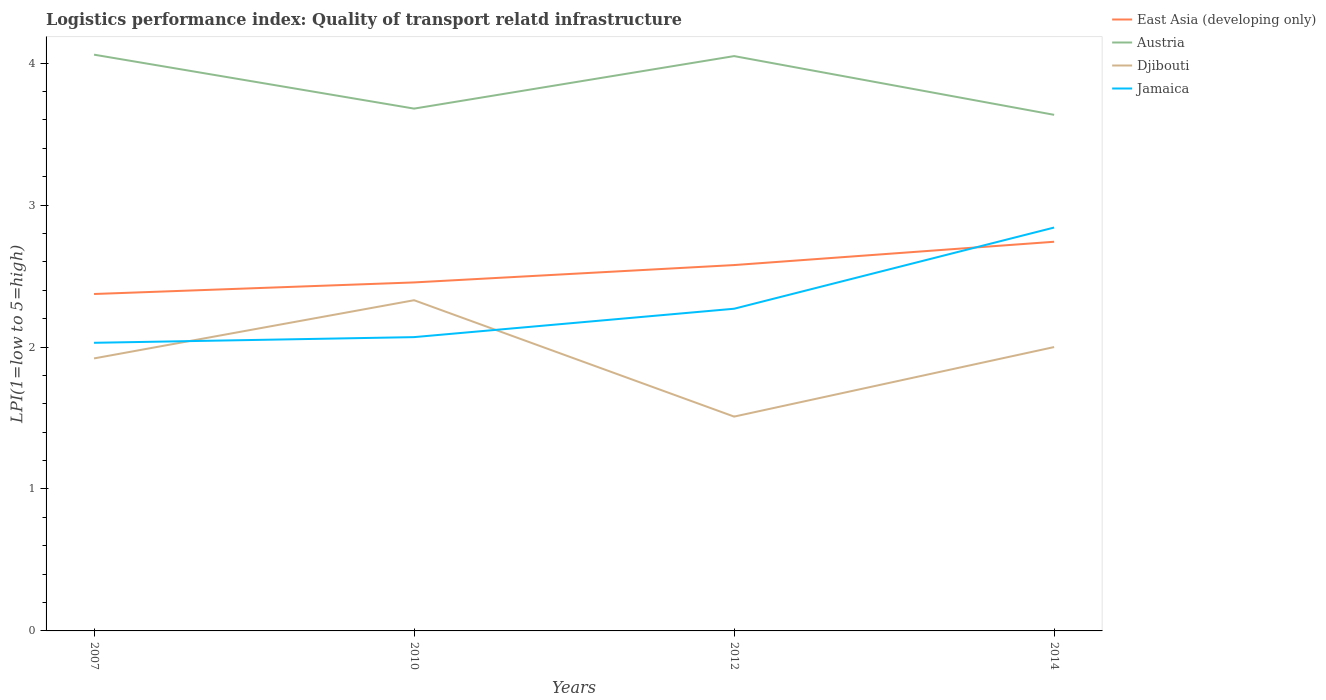How many different coloured lines are there?
Provide a succinct answer. 4. Does the line corresponding to Djibouti intersect with the line corresponding to Jamaica?
Your answer should be compact. Yes. Is the number of lines equal to the number of legend labels?
Give a very brief answer. Yes. Across all years, what is the maximum logistics performance index in Djibouti?
Your answer should be very brief. 1.51. In which year was the logistics performance index in East Asia (developing only) maximum?
Your answer should be compact. 2007. What is the total logistics performance index in Austria in the graph?
Your answer should be very brief. 0.38. What is the difference between the highest and the second highest logistics performance index in Djibouti?
Your response must be concise. 0.82. Is the logistics performance index in East Asia (developing only) strictly greater than the logistics performance index in Austria over the years?
Offer a terse response. Yes. Are the values on the major ticks of Y-axis written in scientific E-notation?
Ensure brevity in your answer.  No. Does the graph contain grids?
Provide a short and direct response. No. Where does the legend appear in the graph?
Make the answer very short. Top right. How many legend labels are there?
Offer a very short reply. 4. How are the legend labels stacked?
Offer a terse response. Vertical. What is the title of the graph?
Provide a short and direct response. Logistics performance index: Quality of transport relatd infrastructure. What is the label or title of the Y-axis?
Provide a short and direct response. LPI(1=low to 5=high). What is the LPI(1=low to 5=high) of East Asia (developing only) in 2007?
Keep it short and to the point. 2.37. What is the LPI(1=low to 5=high) of Austria in 2007?
Your answer should be very brief. 4.06. What is the LPI(1=low to 5=high) of Djibouti in 2007?
Your answer should be very brief. 1.92. What is the LPI(1=low to 5=high) in Jamaica in 2007?
Provide a succinct answer. 2.03. What is the LPI(1=low to 5=high) in East Asia (developing only) in 2010?
Your answer should be very brief. 2.46. What is the LPI(1=low to 5=high) of Austria in 2010?
Your response must be concise. 3.68. What is the LPI(1=low to 5=high) of Djibouti in 2010?
Provide a short and direct response. 2.33. What is the LPI(1=low to 5=high) of Jamaica in 2010?
Your response must be concise. 2.07. What is the LPI(1=low to 5=high) in East Asia (developing only) in 2012?
Make the answer very short. 2.58. What is the LPI(1=low to 5=high) in Austria in 2012?
Your response must be concise. 4.05. What is the LPI(1=low to 5=high) in Djibouti in 2012?
Give a very brief answer. 1.51. What is the LPI(1=low to 5=high) in Jamaica in 2012?
Your answer should be very brief. 2.27. What is the LPI(1=low to 5=high) in East Asia (developing only) in 2014?
Your answer should be compact. 2.74. What is the LPI(1=low to 5=high) in Austria in 2014?
Offer a terse response. 3.64. What is the LPI(1=low to 5=high) in Jamaica in 2014?
Provide a succinct answer. 2.84. Across all years, what is the maximum LPI(1=low to 5=high) of East Asia (developing only)?
Make the answer very short. 2.74. Across all years, what is the maximum LPI(1=low to 5=high) in Austria?
Ensure brevity in your answer.  4.06. Across all years, what is the maximum LPI(1=low to 5=high) in Djibouti?
Your answer should be compact. 2.33. Across all years, what is the maximum LPI(1=low to 5=high) of Jamaica?
Offer a very short reply. 2.84. Across all years, what is the minimum LPI(1=low to 5=high) in East Asia (developing only)?
Provide a succinct answer. 2.37. Across all years, what is the minimum LPI(1=low to 5=high) in Austria?
Provide a short and direct response. 3.64. Across all years, what is the minimum LPI(1=low to 5=high) of Djibouti?
Ensure brevity in your answer.  1.51. Across all years, what is the minimum LPI(1=low to 5=high) of Jamaica?
Make the answer very short. 2.03. What is the total LPI(1=low to 5=high) of East Asia (developing only) in the graph?
Give a very brief answer. 10.15. What is the total LPI(1=low to 5=high) in Austria in the graph?
Your answer should be very brief. 15.43. What is the total LPI(1=low to 5=high) of Djibouti in the graph?
Provide a short and direct response. 7.76. What is the total LPI(1=low to 5=high) of Jamaica in the graph?
Provide a short and direct response. 9.21. What is the difference between the LPI(1=low to 5=high) in East Asia (developing only) in 2007 and that in 2010?
Ensure brevity in your answer.  -0.08. What is the difference between the LPI(1=low to 5=high) of Austria in 2007 and that in 2010?
Keep it short and to the point. 0.38. What is the difference between the LPI(1=low to 5=high) of Djibouti in 2007 and that in 2010?
Keep it short and to the point. -0.41. What is the difference between the LPI(1=low to 5=high) in Jamaica in 2007 and that in 2010?
Offer a very short reply. -0.04. What is the difference between the LPI(1=low to 5=high) in East Asia (developing only) in 2007 and that in 2012?
Your answer should be very brief. -0.2. What is the difference between the LPI(1=low to 5=high) of Djibouti in 2007 and that in 2012?
Ensure brevity in your answer.  0.41. What is the difference between the LPI(1=low to 5=high) in Jamaica in 2007 and that in 2012?
Ensure brevity in your answer.  -0.24. What is the difference between the LPI(1=low to 5=high) in East Asia (developing only) in 2007 and that in 2014?
Offer a very short reply. -0.37. What is the difference between the LPI(1=low to 5=high) in Austria in 2007 and that in 2014?
Give a very brief answer. 0.42. What is the difference between the LPI(1=low to 5=high) of Djibouti in 2007 and that in 2014?
Your response must be concise. -0.08. What is the difference between the LPI(1=low to 5=high) in Jamaica in 2007 and that in 2014?
Make the answer very short. -0.81. What is the difference between the LPI(1=low to 5=high) of East Asia (developing only) in 2010 and that in 2012?
Make the answer very short. -0.12. What is the difference between the LPI(1=low to 5=high) in Austria in 2010 and that in 2012?
Your response must be concise. -0.37. What is the difference between the LPI(1=low to 5=high) in Djibouti in 2010 and that in 2012?
Your response must be concise. 0.82. What is the difference between the LPI(1=low to 5=high) of East Asia (developing only) in 2010 and that in 2014?
Your response must be concise. -0.29. What is the difference between the LPI(1=low to 5=high) of Austria in 2010 and that in 2014?
Your response must be concise. 0.04. What is the difference between the LPI(1=low to 5=high) in Djibouti in 2010 and that in 2014?
Keep it short and to the point. 0.33. What is the difference between the LPI(1=low to 5=high) of Jamaica in 2010 and that in 2014?
Provide a short and direct response. -0.77. What is the difference between the LPI(1=low to 5=high) of East Asia (developing only) in 2012 and that in 2014?
Keep it short and to the point. -0.16. What is the difference between the LPI(1=low to 5=high) of Austria in 2012 and that in 2014?
Provide a succinct answer. 0.41. What is the difference between the LPI(1=low to 5=high) of Djibouti in 2012 and that in 2014?
Provide a short and direct response. -0.49. What is the difference between the LPI(1=low to 5=high) of Jamaica in 2012 and that in 2014?
Offer a terse response. -0.57. What is the difference between the LPI(1=low to 5=high) of East Asia (developing only) in 2007 and the LPI(1=low to 5=high) of Austria in 2010?
Make the answer very short. -1.31. What is the difference between the LPI(1=low to 5=high) of East Asia (developing only) in 2007 and the LPI(1=low to 5=high) of Djibouti in 2010?
Your answer should be very brief. 0.04. What is the difference between the LPI(1=low to 5=high) of East Asia (developing only) in 2007 and the LPI(1=low to 5=high) of Jamaica in 2010?
Keep it short and to the point. 0.3. What is the difference between the LPI(1=low to 5=high) in Austria in 2007 and the LPI(1=low to 5=high) in Djibouti in 2010?
Offer a terse response. 1.73. What is the difference between the LPI(1=low to 5=high) of Austria in 2007 and the LPI(1=low to 5=high) of Jamaica in 2010?
Provide a succinct answer. 1.99. What is the difference between the LPI(1=low to 5=high) in East Asia (developing only) in 2007 and the LPI(1=low to 5=high) in Austria in 2012?
Make the answer very short. -1.68. What is the difference between the LPI(1=low to 5=high) in East Asia (developing only) in 2007 and the LPI(1=low to 5=high) in Djibouti in 2012?
Ensure brevity in your answer.  0.86. What is the difference between the LPI(1=low to 5=high) in East Asia (developing only) in 2007 and the LPI(1=low to 5=high) in Jamaica in 2012?
Offer a terse response. 0.1. What is the difference between the LPI(1=low to 5=high) of Austria in 2007 and the LPI(1=low to 5=high) of Djibouti in 2012?
Your answer should be very brief. 2.55. What is the difference between the LPI(1=low to 5=high) in Austria in 2007 and the LPI(1=low to 5=high) in Jamaica in 2012?
Ensure brevity in your answer.  1.79. What is the difference between the LPI(1=low to 5=high) of Djibouti in 2007 and the LPI(1=low to 5=high) of Jamaica in 2012?
Provide a succinct answer. -0.35. What is the difference between the LPI(1=low to 5=high) in East Asia (developing only) in 2007 and the LPI(1=low to 5=high) in Austria in 2014?
Provide a succinct answer. -1.26. What is the difference between the LPI(1=low to 5=high) of East Asia (developing only) in 2007 and the LPI(1=low to 5=high) of Djibouti in 2014?
Ensure brevity in your answer.  0.37. What is the difference between the LPI(1=low to 5=high) in East Asia (developing only) in 2007 and the LPI(1=low to 5=high) in Jamaica in 2014?
Provide a short and direct response. -0.47. What is the difference between the LPI(1=low to 5=high) of Austria in 2007 and the LPI(1=low to 5=high) of Djibouti in 2014?
Your answer should be compact. 2.06. What is the difference between the LPI(1=low to 5=high) of Austria in 2007 and the LPI(1=low to 5=high) of Jamaica in 2014?
Make the answer very short. 1.22. What is the difference between the LPI(1=low to 5=high) in Djibouti in 2007 and the LPI(1=low to 5=high) in Jamaica in 2014?
Provide a succinct answer. -0.92. What is the difference between the LPI(1=low to 5=high) of East Asia (developing only) in 2010 and the LPI(1=low to 5=high) of Austria in 2012?
Your answer should be very brief. -1.59. What is the difference between the LPI(1=low to 5=high) in East Asia (developing only) in 2010 and the LPI(1=low to 5=high) in Djibouti in 2012?
Offer a terse response. 0.95. What is the difference between the LPI(1=low to 5=high) of East Asia (developing only) in 2010 and the LPI(1=low to 5=high) of Jamaica in 2012?
Provide a succinct answer. 0.19. What is the difference between the LPI(1=low to 5=high) in Austria in 2010 and the LPI(1=low to 5=high) in Djibouti in 2012?
Ensure brevity in your answer.  2.17. What is the difference between the LPI(1=low to 5=high) of Austria in 2010 and the LPI(1=low to 5=high) of Jamaica in 2012?
Ensure brevity in your answer.  1.41. What is the difference between the LPI(1=low to 5=high) of East Asia (developing only) in 2010 and the LPI(1=low to 5=high) of Austria in 2014?
Offer a terse response. -1.18. What is the difference between the LPI(1=low to 5=high) of East Asia (developing only) in 2010 and the LPI(1=low to 5=high) of Djibouti in 2014?
Offer a terse response. 0.46. What is the difference between the LPI(1=low to 5=high) of East Asia (developing only) in 2010 and the LPI(1=low to 5=high) of Jamaica in 2014?
Your answer should be compact. -0.39. What is the difference between the LPI(1=low to 5=high) in Austria in 2010 and the LPI(1=low to 5=high) in Djibouti in 2014?
Make the answer very short. 1.68. What is the difference between the LPI(1=low to 5=high) in Austria in 2010 and the LPI(1=low to 5=high) in Jamaica in 2014?
Provide a succinct answer. 0.84. What is the difference between the LPI(1=low to 5=high) in Djibouti in 2010 and the LPI(1=low to 5=high) in Jamaica in 2014?
Offer a very short reply. -0.51. What is the difference between the LPI(1=low to 5=high) of East Asia (developing only) in 2012 and the LPI(1=low to 5=high) of Austria in 2014?
Offer a terse response. -1.06. What is the difference between the LPI(1=low to 5=high) in East Asia (developing only) in 2012 and the LPI(1=low to 5=high) in Djibouti in 2014?
Offer a terse response. 0.58. What is the difference between the LPI(1=low to 5=high) in East Asia (developing only) in 2012 and the LPI(1=low to 5=high) in Jamaica in 2014?
Give a very brief answer. -0.26. What is the difference between the LPI(1=low to 5=high) in Austria in 2012 and the LPI(1=low to 5=high) in Djibouti in 2014?
Give a very brief answer. 2.05. What is the difference between the LPI(1=low to 5=high) in Austria in 2012 and the LPI(1=low to 5=high) in Jamaica in 2014?
Keep it short and to the point. 1.21. What is the difference between the LPI(1=low to 5=high) of Djibouti in 2012 and the LPI(1=low to 5=high) of Jamaica in 2014?
Keep it short and to the point. -1.33. What is the average LPI(1=low to 5=high) in East Asia (developing only) per year?
Provide a succinct answer. 2.54. What is the average LPI(1=low to 5=high) of Austria per year?
Make the answer very short. 3.86. What is the average LPI(1=low to 5=high) of Djibouti per year?
Your answer should be very brief. 1.94. What is the average LPI(1=low to 5=high) in Jamaica per year?
Make the answer very short. 2.3. In the year 2007, what is the difference between the LPI(1=low to 5=high) in East Asia (developing only) and LPI(1=low to 5=high) in Austria?
Provide a short and direct response. -1.69. In the year 2007, what is the difference between the LPI(1=low to 5=high) in East Asia (developing only) and LPI(1=low to 5=high) in Djibouti?
Give a very brief answer. 0.45. In the year 2007, what is the difference between the LPI(1=low to 5=high) in East Asia (developing only) and LPI(1=low to 5=high) in Jamaica?
Offer a very short reply. 0.34. In the year 2007, what is the difference between the LPI(1=low to 5=high) in Austria and LPI(1=low to 5=high) in Djibouti?
Keep it short and to the point. 2.14. In the year 2007, what is the difference between the LPI(1=low to 5=high) in Austria and LPI(1=low to 5=high) in Jamaica?
Make the answer very short. 2.03. In the year 2007, what is the difference between the LPI(1=low to 5=high) of Djibouti and LPI(1=low to 5=high) of Jamaica?
Your answer should be very brief. -0.11. In the year 2010, what is the difference between the LPI(1=low to 5=high) of East Asia (developing only) and LPI(1=low to 5=high) of Austria?
Provide a succinct answer. -1.22. In the year 2010, what is the difference between the LPI(1=low to 5=high) in East Asia (developing only) and LPI(1=low to 5=high) in Djibouti?
Provide a short and direct response. 0.13. In the year 2010, what is the difference between the LPI(1=low to 5=high) of East Asia (developing only) and LPI(1=low to 5=high) of Jamaica?
Ensure brevity in your answer.  0.39. In the year 2010, what is the difference between the LPI(1=low to 5=high) of Austria and LPI(1=low to 5=high) of Djibouti?
Keep it short and to the point. 1.35. In the year 2010, what is the difference between the LPI(1=low to 5=high) in Austria and LPI(1=low to 5=high) in Jamaica?
Keep it short and to the point. 1.61. In the year 2010, what is the difference between the LPI(1=low to 5=high) of Djibouti and LPI(1=low to 5=high) of Jamaica?
Give a very brief answer. 0.26. In the year 2012, what is the difference between the LPI(1=low to 5=high) of East Asia (developing only) and LPI(1=low to 5=high) of Austria?
Your answer should be very brief. -1.47. In the year 2012, what is the difference between the LPI(1=low to 5=high) of East Asia (developing only) and LPI(1=low to 5=high) of Djibouti?
Your answer should be compact. 1.07. In the year 2012, what is the difference between the LPI(1=low to 5=high) of East Asia (developing only) and LPI(1=low to 5=high) of Jamaica?
Keep it short and to the point. 0.31. In the year 2012, what is the difference between the LPI(1=low to 5=high) of Austria and LPI(1=low to 5=high) of Djibouti?
Provide a succinct answer. 2.54. In the year 2012, what is the difference between the LPI(1=low to 5=high) of Austria and LPI(1=low to 5=high) of Jamaica?
Keep it short and to the point. 1.78. In the year 2012, what is the difference between the LPI(1=low to 5=high) of Djibouti and LPI(1=low to 5=high) of Jamaica?
Make the answer very short. -0.76. In the year 2014, what is the difference between the LPI(1=low to 5=high) of East Asia (developing only) and LPI(1=low to 5=high) of Austria?
Your answer should be compact. -0.89. In the year 2014, what is the difference between the LPI(1=low to 5=high) in East Asia (developing only) and LPI(1=low to 5=high) in Djibouti?
Make the answer very short. 0.74. In the year 2014, what is the difference between the LPI(1=low to 5=high) in East Asia (developing only) and LPI(1=low to 5=high) in Jamaica?
Give a very brief answer. -0.1. In the year 2014, what is the difference between the LPI(1=low to 5=high) of Austria and LPI(1=low to 5=high) of Djibouti?
Make the answer very short. 1.64. In the year 2014, what is the difference between the LPI(1=low to 5=high) in Austria and LPI(1=low to 5=high) in Jamaica?
Ensure brevity in your answer.  0.79. In the year 2014, what is the difference between the LPI(1=low to 5=high) of Djibouti and LPI(1=low to 5=high) of Jamaica?
Offer a terse response. -0.84. What is the ratio of the LPI(1=low to 5=high) of East Asia (developing only) in 2007 to that in 2010?
Give a very brief answer. 0.97. What is the ratio of the LPI(1=low to 5=high) of Austria in 2007 to that in 2010?
Offer a terse response. 1.1. What is the ratio of the LPI(1=low to 5=high) of Djibouti in 2007 to that in 2010?
Your answer should be compact. 0.82. What is the ratio of the LPI(1=low to 5=high) of Jamaica in 2007 to that in 2010?
Make the answer very short. 0.98. What is the ratio of the LPI(1=low to 5=high) in East Asia (developing only) in 2007 to that in 2012?
Your answer should be very brief. 0.92. What is the ratio of the LPI(1=low to 5=high) of Djibouti in 2007 to that in 2012?
Keep it short and to the point. 1.27. What is the ratio of the LPI(1=low to 5=high) of Jamaica in 2007 to that in 2012?
Ensure brevity in your answer.  0.89. What is the ratio of the LPI(1=low to 5=high) in East Asia (developing only) in 2007 to that in 2014?
Your answer should be very brief. 0.87. What is the ratio of the LPI(1=low to 5=high) in Austria in 2007 to that in 2014?
Make the answer very short. 1.12. What is the ratio of the LPI(1=low to 5=high) of Djibouti in 2007 to that in 2014?
Offer a very short reply. 0.96. What is the ratio of the LPI(1=low to 5=high) of Jamaica in 2007 to that in 2014?
Provide a short and direct response. 0.71. What is the ratio of the LPI(1=low to 5=high) in East Asia (developing only) in 2010 to that in 2012?
Offer a very short reply. 0.95. What is the ratio of the LPI(1=low to 5=high) of Austria in 2010 to that in 2012?
Your answer should be compact. 0.91. What is the ratio of the LPI(1=low to 5=high) of Djibouti in 2010 to that in 2012?
Your response must be concise. 1.54. What is the ratio of the LPI(1=low to 5=high) in Jamaica in 2010 to that in 2012?
Your answer should be very brief. 0.91. What is the ratio of the LPI(1=low to 5=high) in East Asia (developing only) in 2010 to that in 2014?
Give a very brief answer. 0.9. What is the ratio of the LPI(1=low to 5=high) in Austria in 2010 to that in 2014?
Offer a terse response. 1.01. What is the ratio of the LPI(1=low to 5=high) of Djibouti in 2010 to that in 2014?
Offer a very short reply. 1.17. What is the ratio of the LPI(1=low to 5=high) of Jamaica in 2010 to that in 2014?
Give a very brief answer. 0.73. What is the ratio of the LPI(1=low to 5=high) in East Asia (developing only) in 2012 to that in 2014?
Your answer should be very brief. 0.94. What is the ratio of the LPI(1=low to 5=high) of Austria in 2012 to that in 2014?
Your answer should be very brief. 1.11. What is the ratio of the LPI(1=low to 5=high) in Djibouti in 2012 to that in 2014?
Provide a succinct answer. 0.76. What is the ratio of the LPI(1=low to 5=high) of Jamaica in 2012 to that in 2014?
Ensure brevity in your answer.  0.8. What is the difference between the highest and the second highest LPI(1=low to 5=high) in East Asia (developing only)?
Make the answer very short. 0.16. What is the difference between the highest and the second highest LPI(1=low to 5=high) of Austria?
Offer a terse response. 0.01. What is the difference between the highest and the second highest LPI(1=low to 5=high) of Djibouti?
Provide a short and direct response. 0.33. What is the difference between the highest and the second highest LPI(1=low to 5=high) in Jamaica?
Provide a succinct answer. 0.57. What is the difference between the highest and the lowest LPI(1=low to 5=high) of East Asia (developing only)?
Keep it short and to the point. 0.37. What is the difference between the highest and the lowest LPI(1=low to 5=high) of Austria?
Your answer should be very brief. 0.42. What is the difference between the highest and the lowest LPI(1=low to 5=high) in Djibouti?
Offer a terse response. 0.82. What is the difference between the highest and the lowest LPI(1=low to 5=high) of Jamaica?
Make the answer very short. 0.81. 